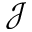<formula> <loc_0><loc_0><loc_500><loc_500>\mathcal { J }</formula> 